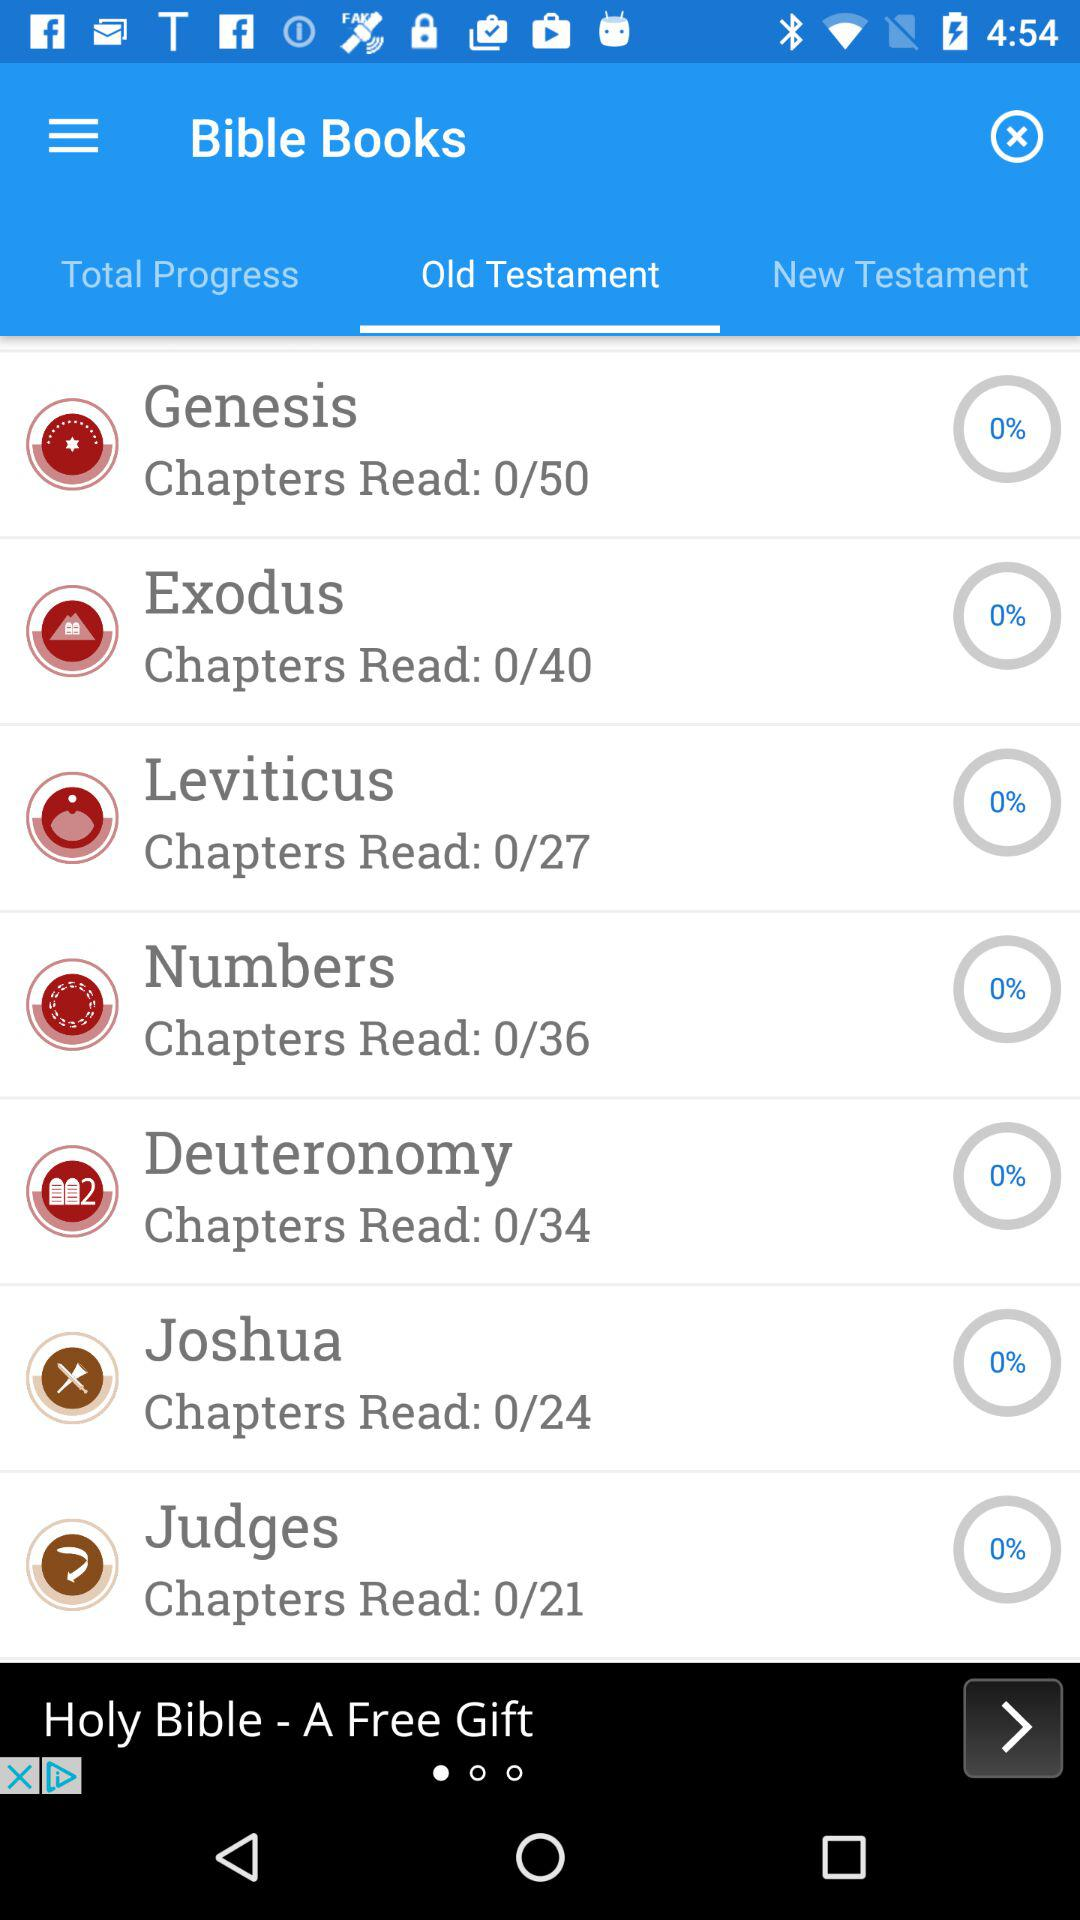What is the name of the book? The names of the books are "Genesis", "Exodus", "Leviticus", "Numbers", "Deuteronomy", "Joshua" and "Judges". 